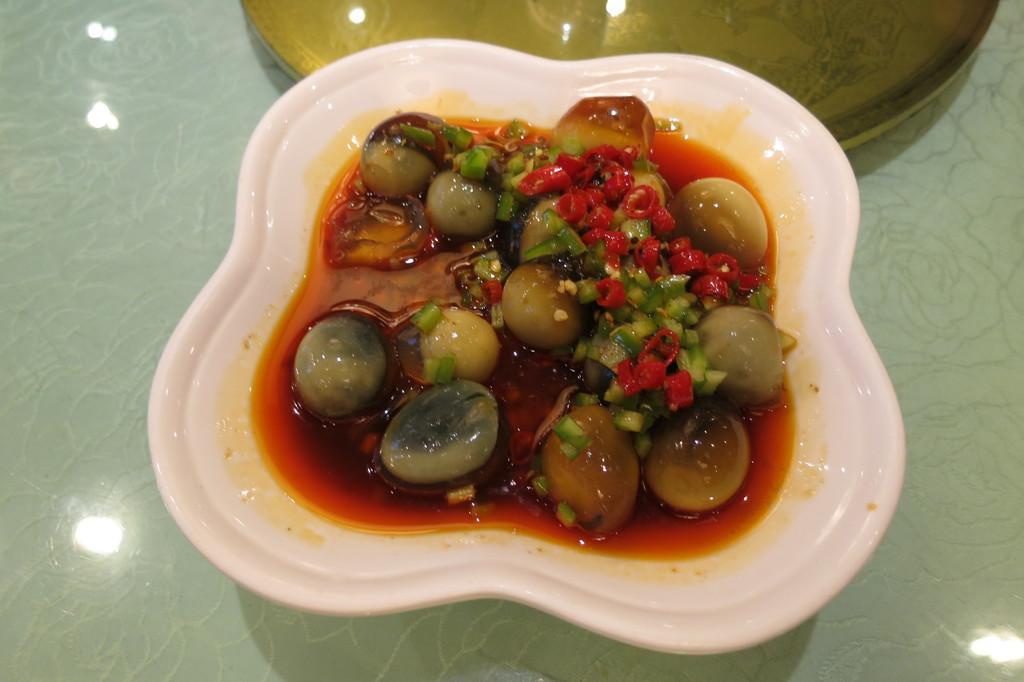Can you describe this image briefly? In this image there is food in the plate. 